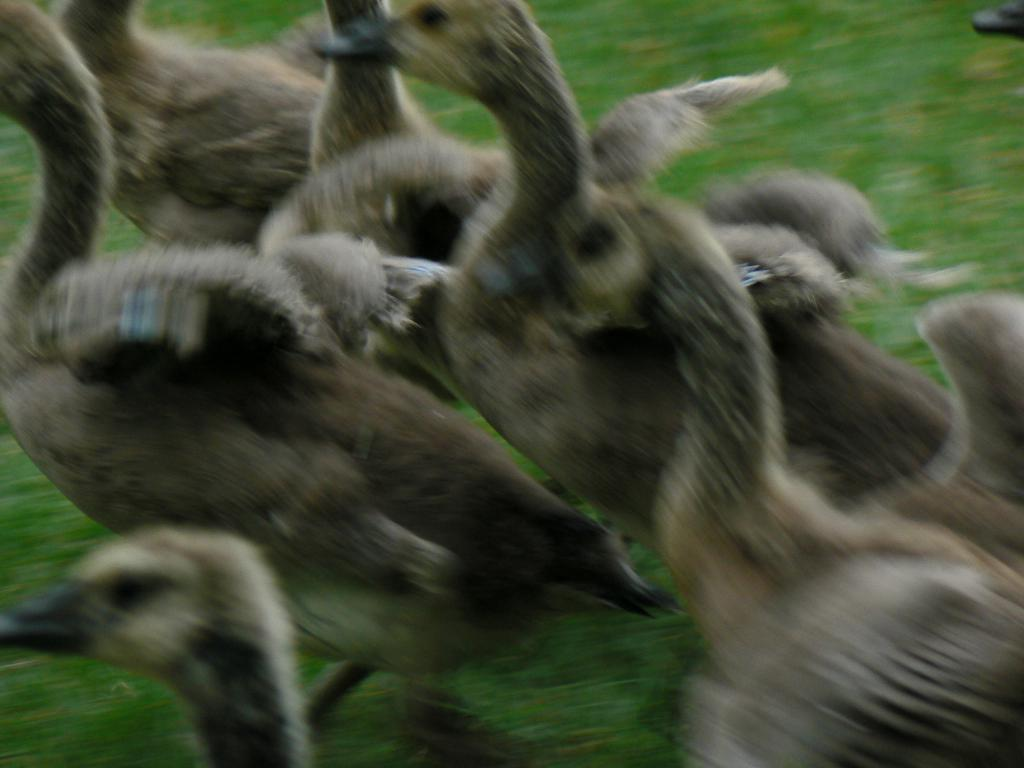What type of animals are on the ground in the image? There are birds on the ground in the image. What can be seen in the background of the image? There is grass visible in the background of the image. Where is the lake located in the image? There is no lake present in the image; it only features birds on the ground and grass in the background. How many spiders can be seen crawling on the birds in the image? There are no spiders present in the image; it only features birds on the ground and grass in the background. 